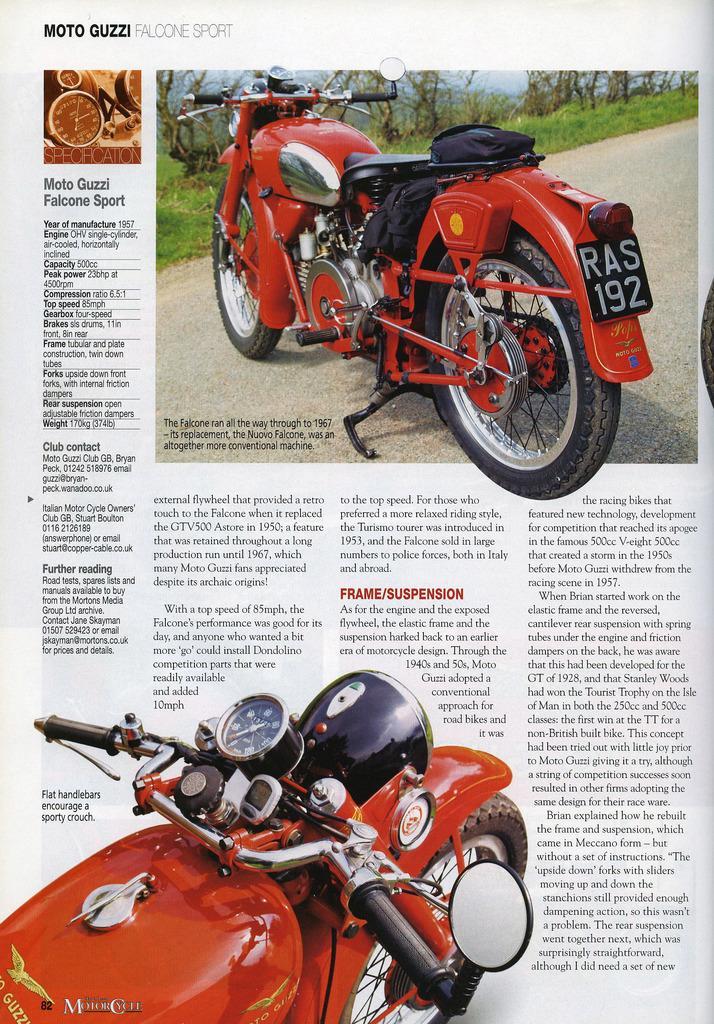How would you summarize this image in a sentence or two? In this image I can see two bike. They are in red and black color. We can see number plate and mirrors. Something is written on it. Back I can see trees and green grass. 